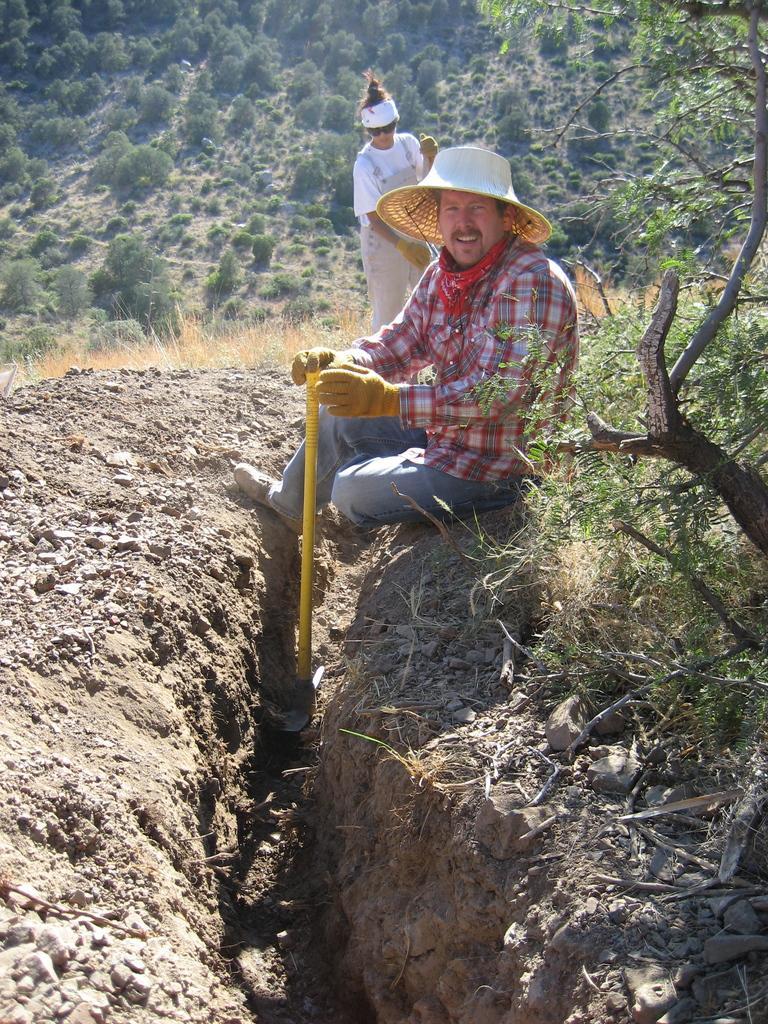How would you summarize this image in a sentence or two? There is a man sitting and holding a tool and wore gloves and hat, behind him there is a person standing and wore gloves. We can see tree and stones. In the background we can see dried grass and trees. 